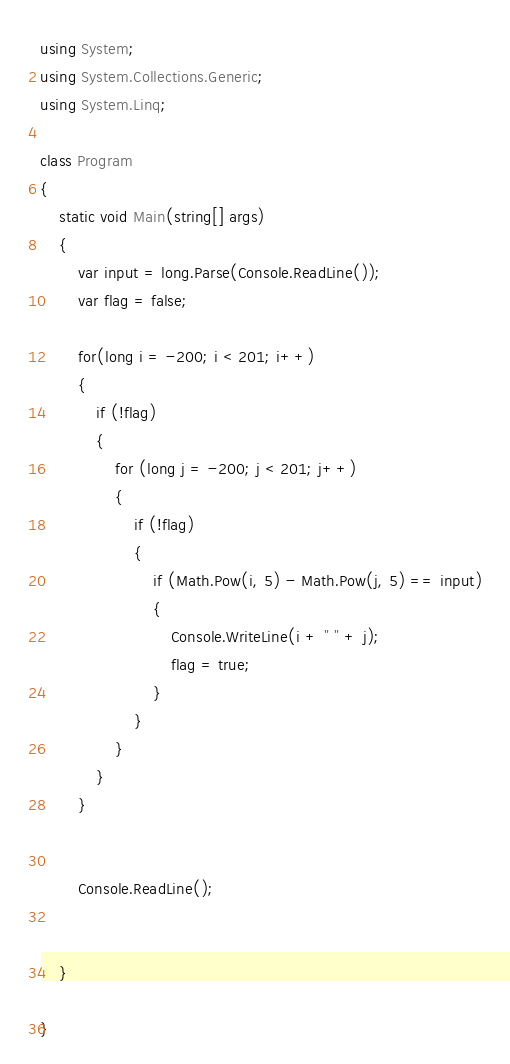<code> <loc_0><loc_0><loc_500><loc_500><_C#_>using System;
using System.Collections.Generic;
using System.Linq;

class Program
{
    static void Main(string[] args)
    {
        var input = long.Parse(Console.ReadLine());
        var flag = false;

        for(long i = -200; i < 201; i++)
        {
            if (!flag)
            {
                for (long j = -200; j < 201; j++)
                {
                    if (!flag)
                    {
                        if (Math.Pow(i, 5) - Math.Pow(j, 5) == input)
                        {
                            Console.WriteLine(i + " " + j);
                            flag = true;
                        }
                    }
                }
            }
        }


        Console.ReadLine();


    }

}

</code> 